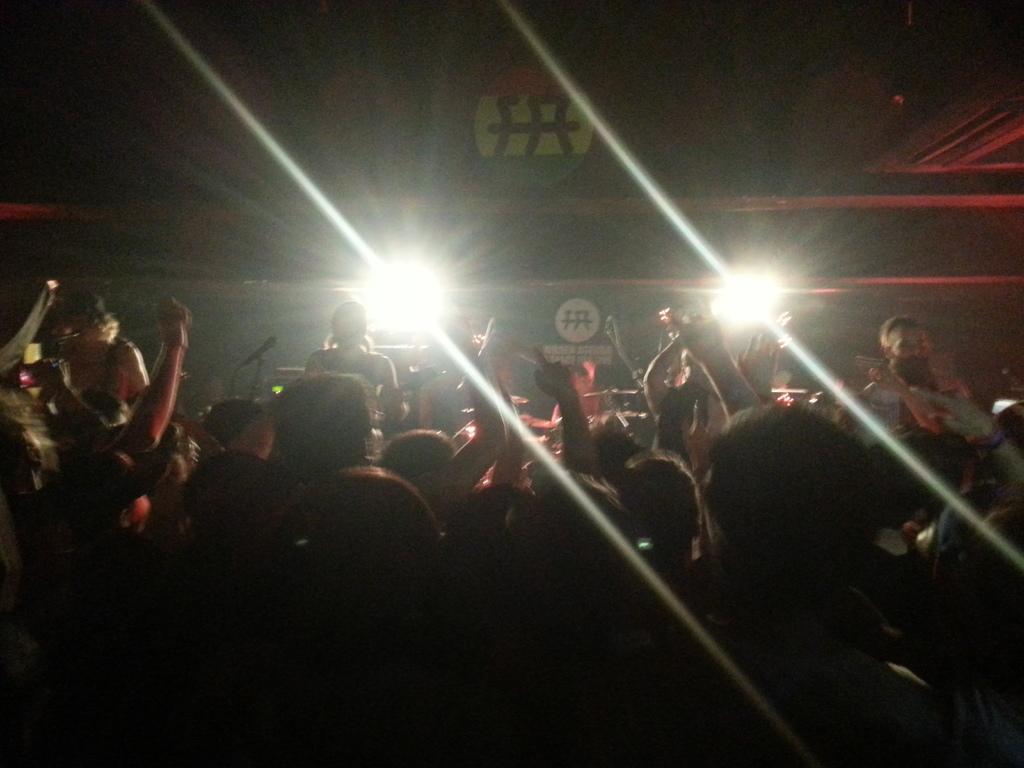Describe this image in one or two sentences. The image is dark. At the bottom there are audience. In the background there are few persons on the stage performing by playing musical instruments and we can also see mike with stand,lights,logos and poles. 